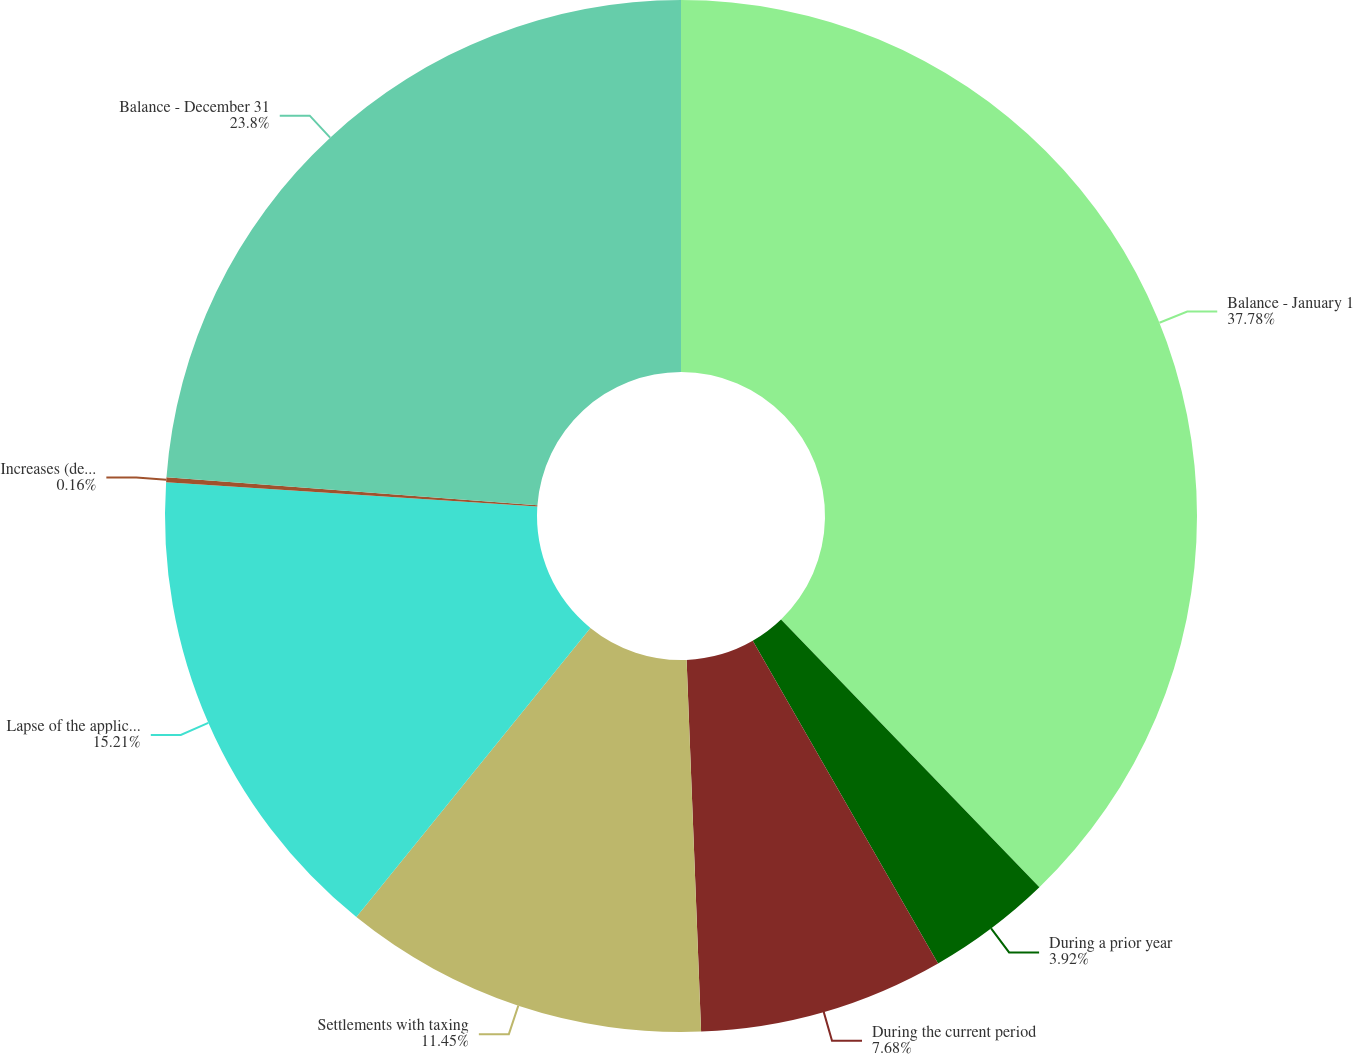<chart> <loc_0><loc_0><loc_500><loc_500><pie_chart><fcel>Balance - January 1<fcel>During a prior year<fcel>During the current period<fcel>Settlements with taxing<fcel>Lapse of the applicable<fcel>Increases (decreases) in<fcel>Balance - December 31<nl><fcel>37.78%<fcel>3.92%<fcel>7.68%<fcel>11.45%<fcel>15.21%<fcel>0.16%<fcel>23.8%<nl></chart> 